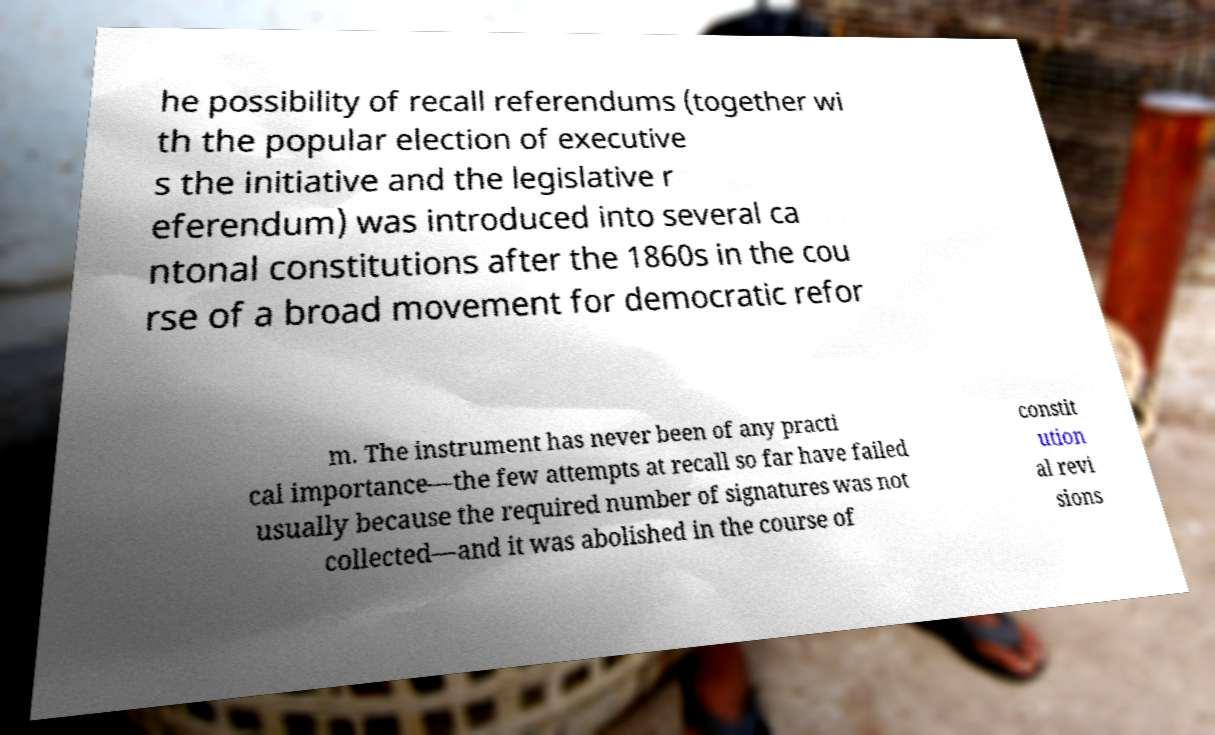There's text embedded in this image that I need extracted. Can you transcribe it verbatim? he possibility of recall referendums (together wi th the popular election of executive s the initiative and the legislative r eferendum) was introduced into several ca ntonal constitutions after the 1860s in the cou rse of a broad movement for democratic refor m. The instrument has never been of any practi cal importance—the few attempts at recall so far have failed usually because the required number of signatures was not collected—and it was abolished in the course of constit ution al revi sions 